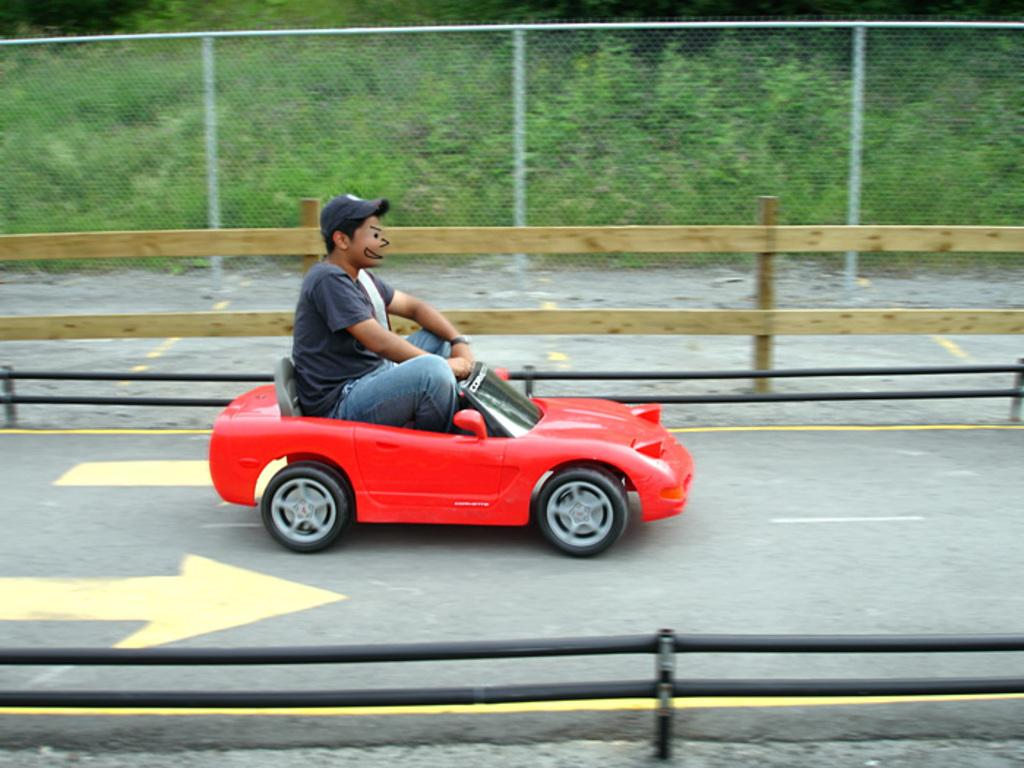What is the man in the image doing? The man is driving a small car in the image. Where is the car located? The car is on a road in the image. What can be seen in the background of the image? There is fencing and trees present in the image. What type of wine is the man drinking while driving in the image? There is no wine present in the image; the man is driving a car. Where is the library located in the image? There is no library present in the image. 